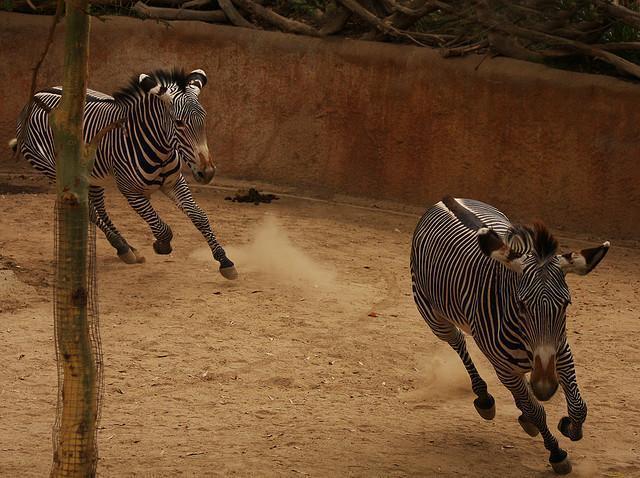How many zebras can be seen?
Give a very brief answer. 2. How many people in the photo?
Give a very brief answer. 0. 